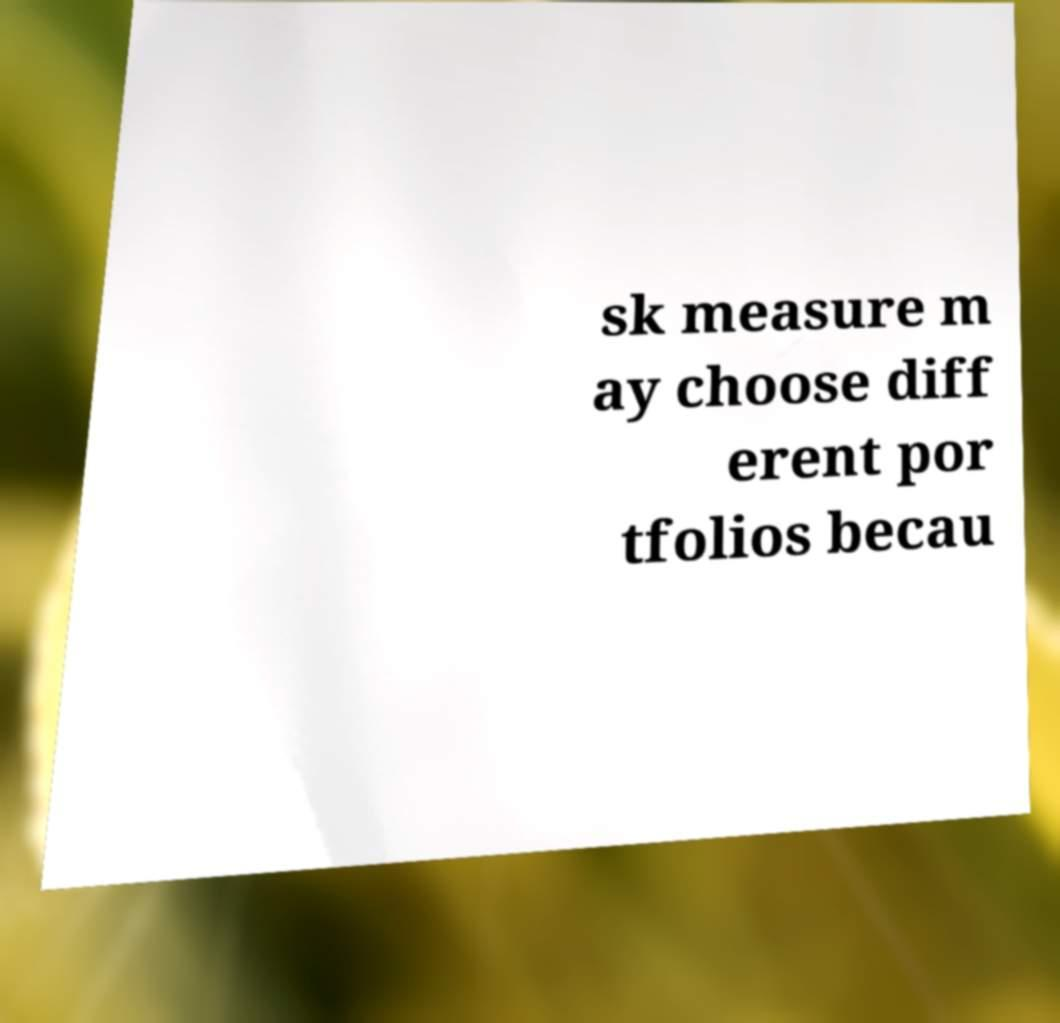What messages or text are displayed in this image? I need them in a readable, typed format. sk measure m ay choose diff erent por tfolios becau 